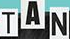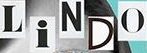Transcribe the words shown in these images in order, separated by a semicolon. TAN; LiNDO 